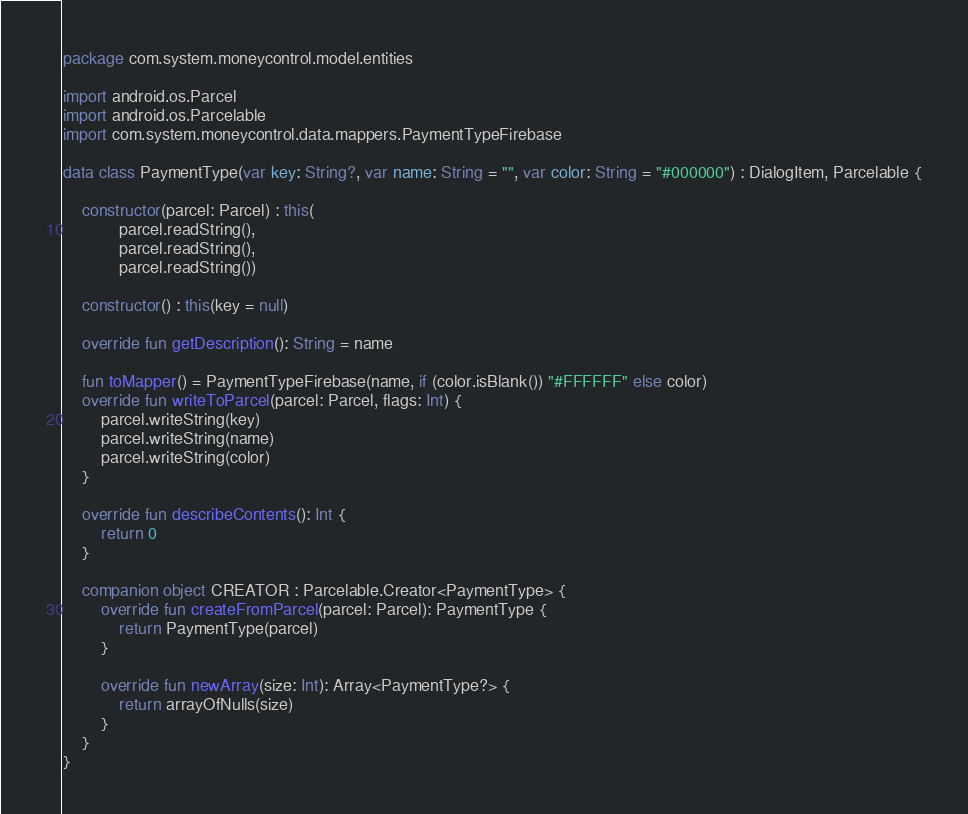Convert code to text. <code><loc_0><loc_0><loc_500><loc_500><_Kotlin_>package com.system.moneycontrol.model.entities

import android.os.Parcel
import android.os.Parcelable
import com.system.moneycontrol.data.mappers.PaymentTypeFirebase

data class PaymentType(var key: String?, var name: String = "", var color: String = "#000000") : DialogItem, Parcelable {

    constructor(parcel: Parcel) : this(
            parcel.readString(),
            parcel.readString(),
            parcel.readString())

    constructor() : this(key = null)

    override fun getDescription(): String = name

    fun toMapper() = PaymentTypeFirebase(name, if (color.isBlank()) "#FFFFFF" else color)
    override fun writeToParcel(parcel: Parcel, flags: Int) {
        parcel.writeString(key)
        parcel.writeString(name)
        parcel.writeString(color)
    }

    override fun describeContents(): Int {
        return 0
    }

    companion object CREATOR : Parcelable.Creator<PaymentType> {
        override fun createFromParcel(parcel: Parcel): PaymentType {
            return PaymentType(parcel)
        }

        override fun newArray(size: Int): Array<PaymentType?> {
            return arrayOfNulls(size)
        }
    }
}</code> 